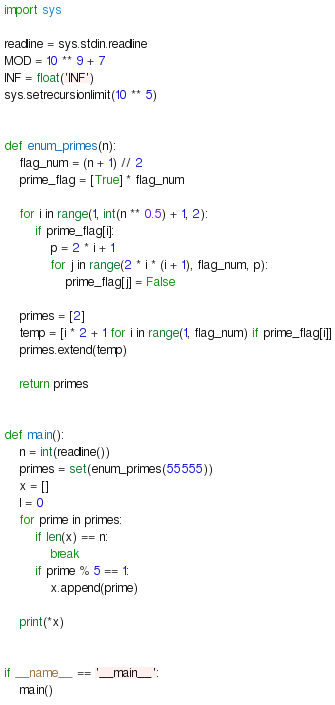Convert code to text. <code><loc_0><loc_0><loc_500><loc_500><_Python_>import sys

readline = sys.stdin.readline
MOD = 10 ** 9 + 7
INF = float('INF')
sys.setrecursionlimit(10 ** 5)


def enum_primes(n):
    flag_num = (n + 1) // 2
    prime_flag = [True] * flag_num

    for i in range(1, int(n ** 0.5) + 1, 2):
        if prime_flag[i]:
            p = 2 * i + 1
            for j in range(2 * i * (i + 1), flag_num, p):
                prime_flag[j] = False

    primes = [2]
    temp = [i * 2 + 1 for i in range(1, flag_num) if prime_flag[i]]
    primes.extend(temp)

    return primes


def main():
    n = int(readline())
    primes = set(enum_primes(55555))
    x = []
    l = 0
    for prime in primes:
        if len(x) == n:
            break
        if prime % 5 == 1:
            x.append(prime)

    print(*x)


if __name__ == '__main__':
    main()
</code> 